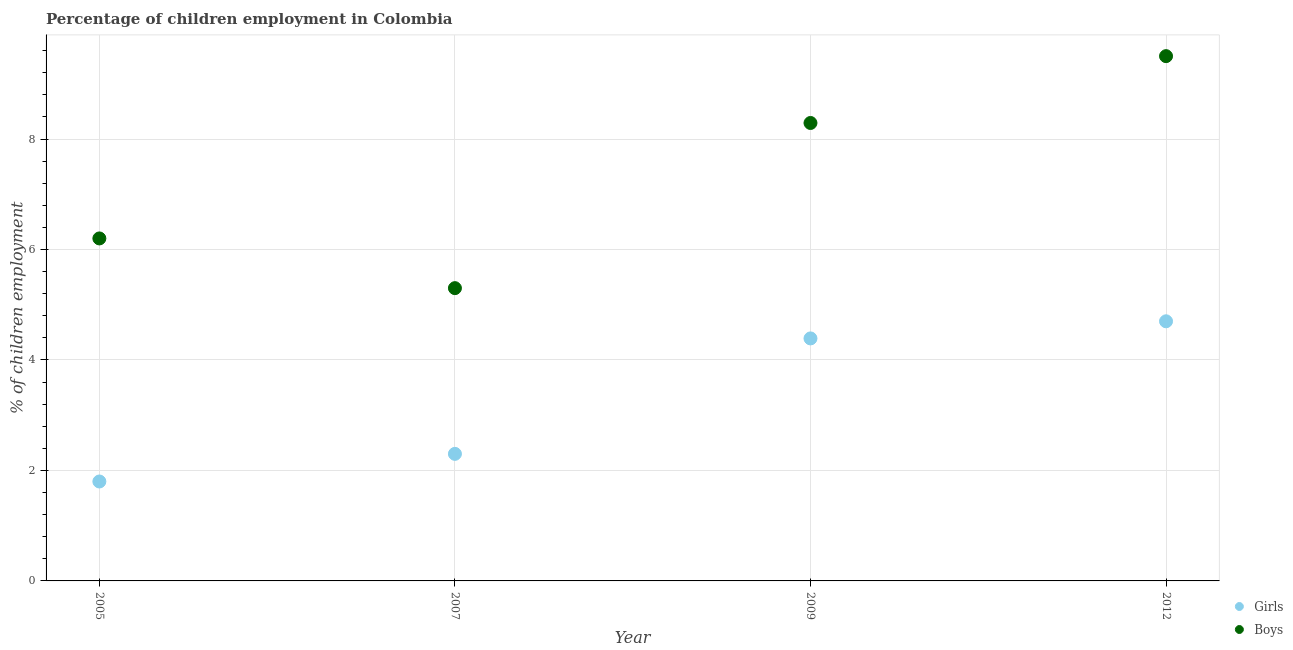How many different coloured dotlines are there?
Provide a succinct answer. 2. Is the number of dotlines equal to the number of legend labels?
Your response must be concise. Yes. What is the percentage of employed girls in 2009?
Your answer should be compact. 4.39. In which year was the percentage of employed boys minimum?
Your answer should be compact. 2007. What is the total percentage of employed girls in the graph?
Give a very brief answer. 13.19. What is the average percentage of employed boys per year?
Your answer should be compact. 7.32. In the year 2007, what is the difference between the percentage of employed boys and percentage of employed girls?
Your response must be concise. 3. In how many years, is the percentage of employed girls greater than 3.6 %?
Offer a very short reply. 2. What is the ratio of the percentage of employed boys in 2005 to that in 2009?
Keep it short and to the point. 0.75. Is the percentage of employed boys in 2007 less than that in 2009?
Provide a succinct answer. Yes. Is the difference between the percentage of employed girls in 2007 and 2009 greater than the difference between the percentage of employed boys in 2007 and 2009?
Your answer should be very brief. Yes. What is the difference between the highest and the second highest percentage of employed boys?
Keep it short and to the point. 1.21. What is the difference between the highest and the lowest percentage of employed boys?
Ensure brevity in your answer.  4.2. Is the sum of the percentage of employed girls in 2007 and 2009 greater than the maximum percentage of employed boys across all years?
Offer a terse response. No. Does the percentage of employed boys monotonically increase over the years?
Provide a short and direct response. No. Is the percentage of employed boys strictly greater than the percentage of employed girls over the years?
Your answer should be very brief. Yes. How many dotlines are there?
Your answer should be compact. 2. How many years are there in the graph?
Offer a terse response. 4. Are the values on the major ticks of Y-axis written in scientific E-notation?
Offer a very short reply. No. Does the graph contain any zero values?
Ensure brevity in your answer.  No. Does the graph contain grids?
Offer a very short reply. Yes. How many legend labels are there?
Your answer should be very brief. 2. How are the legend labels stacked?
Ensure brevity in your answer.  Vertical. What is the title of the graph?
Provide a succinct answer. Percentage of children employment in Colombia. What is the label or title of the X-axis?
Your response must be concise. Year. What is the label or title of the Y-axis?
Offer a very short reply. % of children employment. What is the % of children employment of Boys in 2005?
Offer a terse response. 6.2. What is the % of children employment of Girls in 2007?
Offer a terse response. 2.3. What is the % of children employment in Girls in 2009?
Your response must be concise. 4.39. What is the % of children employment of Boys in 2009?
Your answer should be compact. 8.29. What is the % of children employment of Boys in 2012?
Your answer should be compact. 9.5. What is the total % of children employment in Girls in the graph?
Keep it short and to the point. 13.19. What is the total % of children employment of Boys in the graph?
Make the answer very short. 29.29. What is the difference between the % of children employment of Girls in 2005 and that in 2007?
Make the answer very short. -0.5. What is the difference between the % of children employment of Boys in 2005 and that in 2007?
Ensure brevity in your answer.  0.9. What is the difference between the % of children employment of Girls in 2005 and that in 2009?
Ensure brevity in your answer.  -2.59. What is the difference between the % of children employment in Boys in 2005 and that in 2009?
Make the answer very short. -2.09. What is the difference between the % of children employment of Boys in 2005 and that in 2012?
Ensure brevity in your answer.  -3.3. What is the difference between the % of children employment of Girls in 2007 and that in 2009?
Your response must be concise. -2.09. What is the difference between the % of children employment of Boys in 2007 and that in 2009?
Provide a short and direct response. -2.99. What is the difference between the % of children employment in Girls in 2007 and that in 2012?
Your response must be concise. -2.4. What is the difference between the % of children employment of Boys in 2007 and that in 2012?
Your answer should be compact. -4.2. What is the difference between the % of children employment in Girls in 2009 and that in 2012?
Your response must be concise. -0.31. What is the difference between the % of children employment of Boys in 2009 and that in 2012?
Keep it short and to the point. -1.21. What is the difference between the % of children employment of Girls in 2005 and the % of children employment of Boys in 2007?
Provide a succinct answer. -3.5. What is the difference between the % of children employment in Girls in 2005 and the % of children employment in Boys in 2009?
Offer a terse response. -6.49. What is the difference between the % of children employment in Girls in 2007 and the % of children employment in Boys in 2009?
Offer a terse response. -5.99. What is the difference between the % of children employment in Girls in 2009 and the % of children employment in Boys in 2012?
Make the answer very short. -5.11. What is the average % of children employment in Girls per year?
Provide a succinct answer. 3.3. What is the average % of children employment in Boys per year?
Your answer should be very brief. 7.32. In the year 2005, what is the difference between the % of children employment of Girls and % of children employment of Boys?
Offer a very short reply. -4.4. In the year 2009, what is the difference between the % of children employment of Girls and % of children employment of Boys?
Ensure brevity in your answer.  -3.9. In the year 2012, what is the difference between the % of children employment in Girls and % of children employment in Boys?
Offer a very short reply. -4.8. What is the ratio of the % of children employment of Girls in 2005 to that in 2007?
Keep it short and to the point. 0.78. What is the ratio of the % of children employment in Boys in 2005 to that in 2007?
Provide a short and direct response. 1.17. What is the ratio of the % of children employment of Girls in 2005 to that in 2009?
Ensure brevity in your answer.  0.41. What is the ratio of the % of children employment in Boys in 2005 to that in 2009?
Offer a terse response. 0.75. What is the ratio of the % of children employment of Girls in 2005 to that in 2012?
Offer a terse response. 0.38. What is the ratio of the % of children employment in Boys in 2005 to that in 2012?
Provide a short and direct response. 0.65. What is the ratio of the % of children employment of Girls in 2007 to that in 2009?
Provide a short and direct response. 0.52. What is the ratio of the % of children employment in Boys in 2007 to that in 2009?
Provide a short and direct response. 0.64. What is the ratio of the % of children employment in Girls in 2007 to that in 2012?
Provide a succinct answer. 0.49. What is the ratio of the % of children employment of Boys in 2007 to that in 2012?
Ensure brevity in your answer.  0.56. What is the ratio of the % of children employment in Girls in 2009 to that in 2012?
Make the answer very short. 0.93. What is the ratio of the % of children employment of Boys in 2009 to that in 2012?
Your response must be concise. 0.87. What is the difference between the highest and the second highest % of children employment in Girls?
Keep it short and to the point. 0.31. What is the difference between the highest and the second highest % of children employment of Boys?
Offer a terse response. 1.21. What is the difference between the highest and the lowest % of children employment of Girls?
Give a very brief answer. 2.9. 